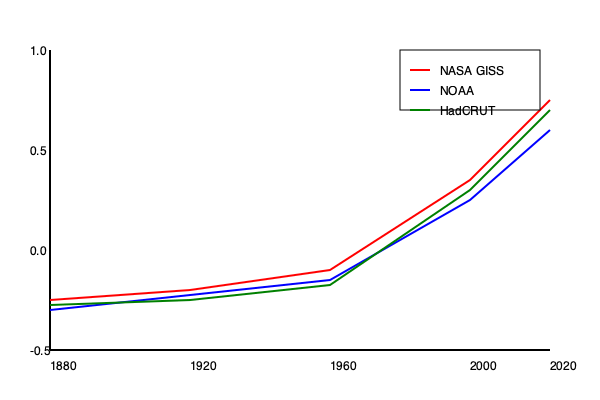Analyzing the global temperature anomaly data from NASA GISS, NOAA, and HadCRUT, what is the approximate difference in temperature anomaly between 1880 and 2020, and what does this suggest about the rate of global warming over the past century? To answer this question, we need to follow these steps:

1. Identify the starting and ending points for each dataset:
   - NASA GISS (red line): 1880: ~-0.2°C, 2020: ~1.0°C
   - NOAA (blue line): 1880: ~-0.15°C, 2020: ~0.9°C
   - HadCRUT (green line): 1880: ~-0.18°C, 2020: ~0.95°C

2. Calculate the temperature anomaly difference for each dataset:
   - NASA GISS: 1.0 - (-0.2) = 1.2°C
   - NOAA: 0.9 - (-0.15) = 1.05°C
   - HadCRUT: 0.95 - (-0.18) = 1.13°C

3. Calculate the average difference across all three datasets:
   $(1.2 + 1.05 + 1.13) / 3 \approx 1.13°C$

4. Interpret the results:
   - The average temperature anomaly increase of approximately 1.13°C over 140 years indicates a significant warming trend.
   - This warming rate is unprecedented in recent geological history and aligns with the scientific consensus on human-induced climate change.
   - The consistency across different datasets (NASA GISS, NOAA, and HadCRUT) strengthens the reliability of this warming trend observation.

5. Consider the implications:
   - This rapid warming trend has serious implications for global climate systems, ecosystems, and human societies.
   - The rate of warming appears to be accelerating, especially in recent decades, as shown by the steeper curve towards the end of the graph.
Answer: Approximately 1.13°C increase, indicating significant and accelerating global warming over the past century. 